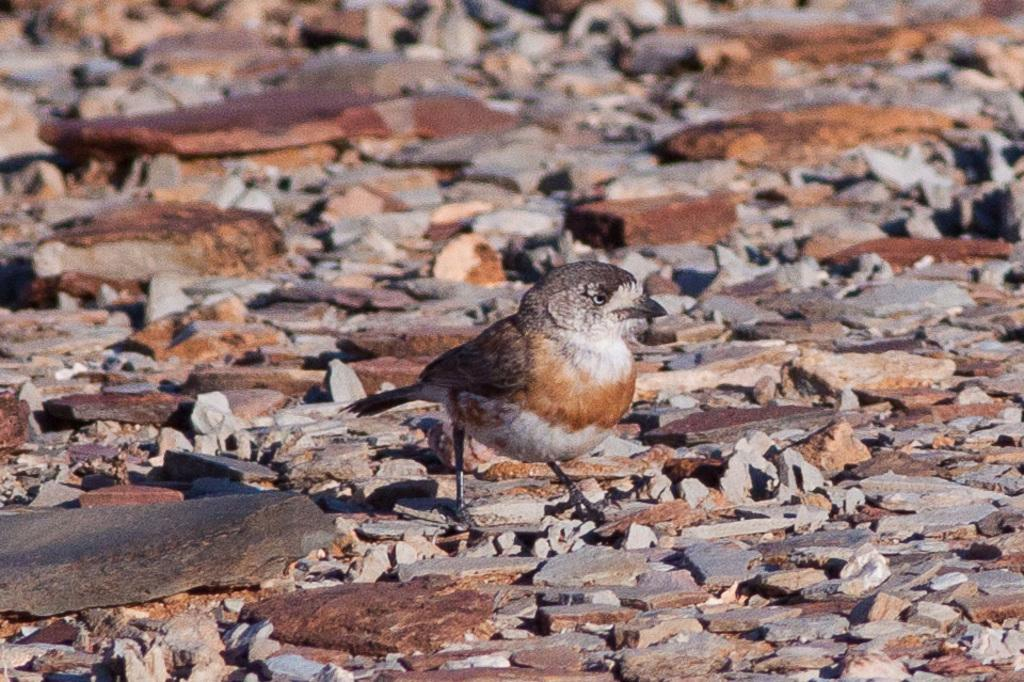What type of animal can be seen in the image? There is a bird in the image. What other objects or elements are present in the image? There are rocks in the image. What design is featured on the cracker in the image? There is: There is no cracker present in the image, so it is not possible to answer that question. 